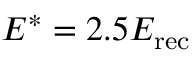Convert formula to latex. <formula><loc_0><loc_0><loc_500><loc_500>E ^ { * } = 2 . 5 E _ { r e c }</formula> 